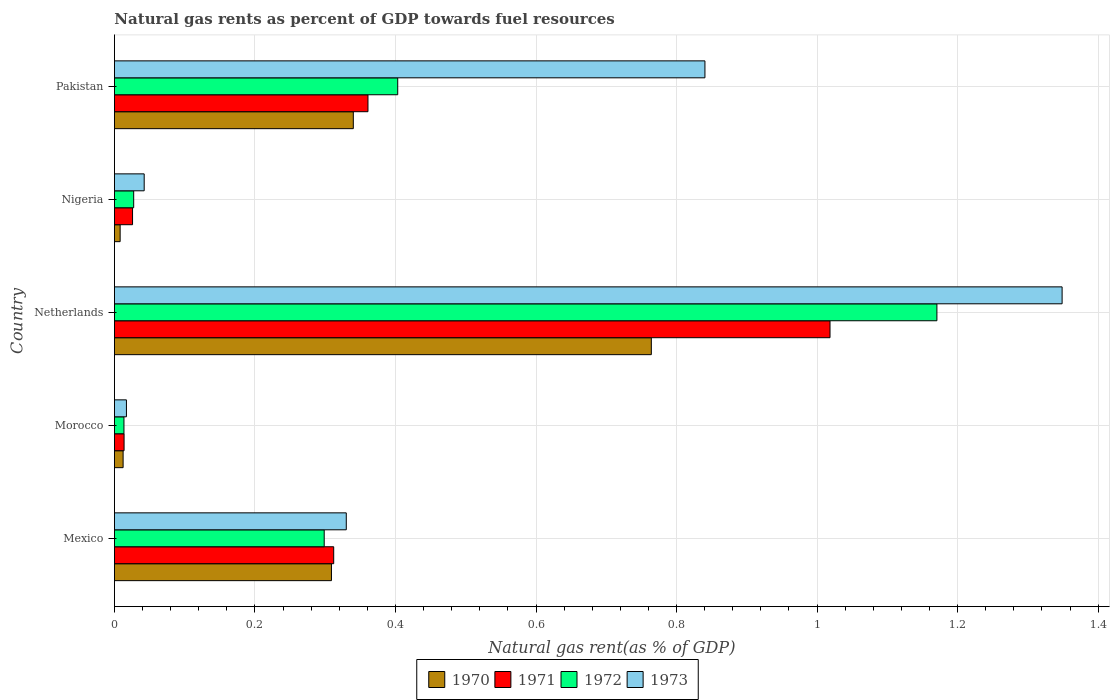How many different coloured bars are there?
Provide a short and direct response. 4. How many groups of bars are there?
Your response must be concise. 5. Are the number of bars on each tick of the Y-axis equal?
Provide a succinct answer. Yes. How many bars are there on the 3rd tick from the bottom?
Make the answer very short. 4. What is the label of the 5th group of bars from the top?
Provide a short and direct response. Mexico. In how many cases, is the number of bars for a given country not equal to the number of legend labels?
Provide a short and direct response. 0. What is the natural gas rent in 1970 in Pakistan?
Your answer should be compact. 0.34. Across all countries, what is the maximum natural gas rent in 1972?
Ensure brevity in your answer.  1.17. Across all countries, what is the minimum natural gas rent in 1970?
Offer a very short reply. 0.01. In which country was the natural gas rent in 1971 maximum?
Give a very brief answer. Netherlands. In which country was the natural gas rent in 1973 minimum?
Offer a terse response. Morocco. What is the total natural gas rent in 1971 in the graph?
Your answer should be compact. 1.73. What is the difference between the natural gas rent in 1972 in Mexico and that in Netherlands?
Ensure brevity in your answer.  -0.87. What is the difference between the natural gas rent in 1972 in Nigeria and the natural gas rent in 1970 in Pakistan?
Keep it short and to the point. -0.31. What is the average natural gas rent in 1973 per country?
Provide a succinct answer. 0.52. What is the difference between the natural gas rent in 1972 and natural gas rent in 1970 in Nigeria?
Your response must be concise. 0.02. What is the ratio of the natural gas rent in 1972 in Nigeria to that in Pakistan?
Your response must be concise. 0.07. Is the natural gas rent in 1970 in Mexico less than that in Nigeria?
Give a very brief answer. No. What is the difference between the highest and the second highest natural gas rent in 1973?
Keep it short and to the point. 0.51. What is the difference between the highest and the lowest natural gas rent in 1971?
Offer a very short reply. 1. In how many countries, is the natural gas rent in 1971 greater than the average natural gas rent in 1971 taken over all countries?
Ensure brevity in your answer.  2. Is it the case that in every country, the sum of the natural gas rent in 1973 and natural gas rent in 1970 is greater than the sum of natural gas rent in 1971 and natural gas rent in 1972?
Keep it short and to the point. No. What does the 2nd bar from the top in Mexico represents?
Offer a very short reply. 1972. How many bars are there?
Your answer should be very brief. 20. Are all the bars in the graph horizontal?
Give a very brief answer. Yes. How many countries are there in the graph?
Your answer should be very brief. 5. Are the values on the major ticks of X-axis written in scientific E-notation?
Offer a very short reply. No. Does the graph contain grids?
Your response must be concise. Yes. What is the title of the graph?
Give a very brief answer. Natural gas rents as percent of GDP towards fuel resources. Does "2002" appear as one of the legend labels in the graph?
Provide a succinct answer. No. What is the label or title of the X-axis?
Your answer should be compact. Natural gas rent(as % of GDP). What is the label or title of the Y-axis?
Ensure brevity in your answer.  Country. What is the Natural gas rent(as % of GDP) of 1970 in Mexico?
Keep it short and to the point. 0.31. What is the Natural gas rent(as % of GDP) in 1971 in Mexico?
Provide a short and direct response. 0.31. What is the Natural gas rent(as % of GDP) of 1972 in Mexico?
Offer a terse response. 0.3. What is the Natural gas rent(as % of GDP) of 1973 in Mexico?
Give a very brief answer. 0.33. What is the Natural gas rent(as % of GDP) in 1970 in Morocco?
Give a very brief answer. 0.01. What is the Natural gas rent(as % of GDP) of 1971 in Morocco?
Provide a succinct answer. 0.01. What is the Natural gas rent(as % of GDP) of 1972 in Morocco?
Offer a terse response. 0.01. What is the Natural gas rent(as % of GDP) in 1973 in Morocco?
Provide a succinct answer. 0.02. What is the Natural gas rent(as % of GDP) in 1970 in Netherlands?
Your answer should be very brief. 0.76. What is the Natural gas rent(as % of GDP) of 1971 in Netherlands?
Give a very brief answer. 1.02. What is the Natural gas rent(as % of GDP) of 1972 in Netherlands?
Your response must be concise. 1.17. What is the Natural gas rent(as % of GDP) in 1973 in Netherlands?
Your answer should be very brief. 1.35. What is the Natural gas rent(as % of GDP) of 1970 in Nigeria?
Keep it short and to the point. 0.01. What is the Natural gas rent(as % of GDP) of 1971 in Nigeria?
Your answer should be very brief. 0.03. What is the Natural gas rent(as % of GDP) of 1972 in Nigeria?
Make the answer very short. 0.03. What is the Natural gas rent(as % of GDP) in 1973 in Nigeria?
Your response must be concise. 0.04. What is the Natural gas rent(as % of GDP) of 1970 in Pakistan?
Offer a terse response. 0.34. What is the Natural gas rent(as % of GDP) in 1971 in Pakistan?
Give a very brief answer. 0.36. What is the Natural gas rent(as % of GDP) of 1972 in Pakistan?
Your answer should be compact. 0.4. What is the Natural gas rent(as % of GDP) of 1973 in Pakistan?
Offer a very short reply. 0.84. Across all countries, what is the maximum Natural gas rent(as % of GDP) of 1970?
Ensure brevity in your answer.  0.76. Across all countries, what is the maximum Natural gas rent(as % of GDP) of 1971?
Keep it short and to the point. 1.02. Across all countries, what is the maximum Natural gas rent(as % of GDP) in 1972?
Keep it short and to the point. 1.17. Across all countries, what is the maximum Natural gas rent(as % of GDP) of 1973?
Offer a terse response. 1.35. Across all countries, what is the minimum Natural gas rent(as % of GDP) of 1970?
Keep it short and to the point. 0.01. Across all countries, what is the minimum Natural gas rent(as % of GDP) of 1971?
Offer a very short reply. 0.01. Across all countries, what is the minimum Natural gas rent(as % of GDP) in 1972?
Provide a short and direct response. 0.01. Across all countries, what is the minimum Natural gas rent(as % of GDP) of 1973?
Keep it short and to the point. 0.02. What is the total Natural gas rent(as % of GDP) in 1970 in the graph?
Offer a very short reply. 1.43. What is the total Natural gas rent(as % of GDP) of 1971 in the graph?
Provide a succinct answer. 1.73. What is the total Natural gas rent(as % of GDP) of 1972 in the graph?
Provide a succinct answer. 1.91. What is the total Natural gas rent(as % of GDP) of 1973 in the graph?
Give a very brief answer. 2.58. What is the difference between the Natural gas rent(as % of GDP) in 1970 in Mexico and that in Morocco?
Keep it short and to the point. 0.3. What is the difference between the Natural gas rent(as % of GDP) of 1971 in Mexico and that in Morocco?
Your response must be concise. 0.3. What is the difference between the Natural gas rent(as % of GDP) of 1972 in Mexico and that in Morocco?
Make the answer very short. 0.28. What is the difference between the Natural gas rent(as % of GDP) in 1973 in Mexico and that in Morocco?
Ensure brevity in your answer.  0.31. What is the difference between the Natural gas rent(as % of GDP) in 1970 in Mexico and that in Netherlands?
Ensure brevity in your answer.  -0.46. What is the difference between the Natural gas rent(as % of GDP) of 1971 in Mexico and that in Netherlands?
Offer a terse response. -0.71. What is the difference between the Natural gas rent(as % of GDP) of 1972 in Mexico and that in Netherlands?
Your answer should be very brief. -0.87. What is the difference between the Natural gas rent(as % of GDP) of 1973 in Mexico and that in Netherlands?
Your answer should be compact. -1.02. What is the difference between the Natural gas rent(as % of GDP) of 1970 in Mexico and that in Nigeria?
Your response must be concise. 0.3. What is the difference between the Natural gas rent(as % of GDP) of 1971 in Mexico and that in Nigeria?
Provide a short and direct response. 0.29. What is the difference between the Natural gas rent(as % of GDP) of 1972 in Mexico and that in Nigeria?
Give a very brief answer. 0.27. What is the difference between the Natural gas rent(as % of GDP) in 1973 in Mexico and that in Nigeria?
Your answer should be very brief. 0.29. What is the difference between the Natural gas rent(as % of GDP) in 1970 in Mexico and that in Pakistan?
Ensure brevity in your answer.  -0.03. What is the difference between the Natural gas rent(as % of GDP) in 1971 in Mexico and that in Pakistan?
Offer a terse response. -0.05. What is the difference between the Natural gas rent(as % of GDP) in 1972 in Mexico and that in Pakistan?
Offer a very short reply. -0.1. What is the difference between the Natural gas rent(as % of GDP) in 1973 in Mexico and that in Pakistan?
Ensure brevity in your answer.  -0.51. What is the difference between the Natural gas rent(as % of GDP) of 1970 in Morocco and that in Netherlands?
Offer a terse response. -0.75. What is the difference between the Natural gas rent(as % of GDP) of 1971 in Morocco and that in Netherlands?
Offer a terse response. -1. What is the difference between the Natural gas rent(as % of GDP) of 1972 in Morocco and that in Netherlands?
Give a very brief answer. -1.16. What is the difference between the Natural gas rent(as % of GDP) of 1973 in Morocco and that in Netherlands?
Offer a terse response. -1.33. What is the difference between the Natural gas rent(as % of GDP) in 1970 in Morocco and that in Nigeria?
Ensure brevity in your answer.  0. What is the difference between the Natural gas rent(as % of GDP) in 1971 in Morocco and that in Nigeria?
Your answer should be compact. -0.01. What is the difference between the Natural gas rent(as % of GDP) in 1972 in Morocco and that in Nigeria?
Give a very brief answer. -0.01. What is the difference between the Natural gas rent(as % of GDP) in 1973 in Morocco and that in Nigeria?
Give a very brief answer. -0.03. What is the difference between the Natural gas rent(as % of GDP) of 1970 in Morocco and that in Pakistan?
Your response must be concise. -0.33. What is the difference between the Natural gas rent(as % of GDP) of 1971 in Morocco and that in Pakistan?
Offer a terse response. -0.35. What is the difference between the Natural gas rent(as % of GDP) in 1972 in Morocco and that in Pakistan?
Your response must be concise. -0.39. What is the difference between the Natural gas rent(as % of GDP) in 1973 in Morocco and that in Pakistan?
Your answer should be compact. -0.82. What is the difference between the Natural gas rent(as % of GDP) of 1970 in Netherlands and that in Nigeria?
Make the answer very short. 0.76. What is the difference between the Natural gas rent(as % of GDP) in 1971 in Netherlands and that in Nigeria?
Give a very brief answer. 0.99. What is the difference between the Natural gas rent(as % of GDP) in 1972 in Netherlands and that in Nigeria?
Your answer should be very brief. 1.14. What is the difference between the Natural gas rent(as % of GDP) in 1973 in Netherlands and that in Nigeria?
Provide a short and direct response. 1.31. What is the difference between the Natural gas rent(as % of GDP) of 1970 in Netherlands and that in Pakistan?
Make the answer very short. 0.42. What is the difference between the Natural gas rent(as % of GDP) of 1971 in Netherlands and that in Pakistan?
Your answer should be very brief. 0.66. What is the difference between the Natural gas rent(as % of GDP) of 1972 in Netherlands and that in Pakistan?
Offer a very short reply. 0.77. What is the difference between the Natural gas rent(as % of GDP) of 1973 in Netherlands and that in Pakistan?
Your answer should be compact. 0.51. What is the difference between the Natural gas rent(as % of GDP) of 1970 in Nigeria and that in Pakistan?
Provide a succinct answer. -0.33. What is the difference between the Natural gas rent(as % of GDP) in 1971 in Nigeria and that in Pakistan?
Provide a short and direct response. -0.34. What is the difference between the Natural gas rent(as % of GDP) of 1972 in Nigeria and that in Pakistan?
Make the answer very short. -0.38. What is the difference between the Natural gas rent(as % of GDP) of 1973 in Nigeria and that in Pakistan?
Offer a very short reply. -0.8. What is the difference between the Natural gas rent(as % of GDP) of 1970 in Mexico and the Natural gas rent(as % of GDP) of 1971 in Morocco?
Your answer should be compact. 0.3. What is the difference between the Natural gas rent(as % of GDP) of 1970 in Mexico and the Natural gas rent(as % of GDP) of 1972 in Morocco?
Offer a terse response. 0.3. What is the difference between the Natural gas rent(as % of GDP) in 1970 in Mexico and the Natural gas rent(as % of GDP) in 1973 in Morocco?
Ensure brevity in your answer.  0.29. What is the difference between the Natural gas rent(as % of GDP) in 1971 in Mexico and the Natural gas rent(as % of GDP) in 1972 in Morocco?
Make the answer very short. 0.3. What is the difference between the Natural gas rent(as % of GDP) of 1971 in Mexico and the Natural gas rent(as % of GDP) of 1973 in Morocco?
Offer a very short reply. 0.29. What is the difference between the Natural gas rent(as % of GDP) in 1972 in Mexico and the Natural gas rent(as % of GDP) in 1973 in Morocco?
Offer a very short reply. 0.28. What is the difference between the Natural gas rent(as % of GDP) of 1970 in Mexico and the Natural gas rent(as % of GDP) of 1971 in Netherlands?
Give a very brief answer. -0.71. What is the difference between the Natural gas rent(as % of GDP) in 1970 in Mexico and the Natural gas rent(as % of GDP) in 1972 in Netherlands?
Your answer should be compact. -0.86. What is the difference between the Natural gas rent(as % of GDP) in 1970 in Mexico and the Natural gas rent(as % of GDP) in 1973 in Netherlands?
Keep it short and to the point. -1.04. What is the difference between the Natural gas rent(as % of GDP) in 1971 in Mexico and the Natural gas rent(as % of GDP) in 1972 in Netherlands?
Your answer should be compact. -0.86. What is the difference between the Natural gas rent(as % of GDP) of 1971 in Mexico and the Natural gas rent(as % of GDP) of 1973 in Netherlands?
Provide a succinct answer. -1.04. What is the difference between the Natural gas rent(as % of GDP) of 1972 in Mexico and the Natural gas rent(as % of GDP) of 1973 in Netherlands?
Your answer should be compact. -1.05. What is the difference between the Natural gas rent(as % of GDP) of 1970 in Mexico and the Natural gas rent(as % of GDP) of 1971 in Nigeria?
Offer a terse response. 0.28. What is the difference between the Natural gas rent(as % of GDP) in 1970 in Mexico and the Natural gas rent(as % of GDP) in 1972 in Nigeria?
Your answer should be compact. 0.28. What is the difference between the Natural gas rent(as % of GDP) of 1970 in Mexico and the Natural gas rent(as % of GDP) of 1973 in Nigeria?
Provide a short and direct response. 0.27. What is the difference between the Natural gas rent(as % of GDP) of 1971 in Mexico and the Natural gas rent(as % of GDP) of 1972 in Nigeria?
Offer a very short reply. 0.28. What is the difference between the Natural gas rent(as % of GDP) in 1971 in Mexico and the Natural gas rent(as % of GDP) in 1973 in Nigeria?
Give a very brief answer. 0.27. What is the difference between the Natural gas rent(as % of GDP) of 1972 in Mexico and the Natural gas rent(as % of GDP) of 1973 in Nigeria?
Give a very brief answer. 0.26. What is the difference between the Natural gas rent(as % of GDP) of 1970 in Mexico and the Natural gas rent(as % of GDP) of 1971 in Pakistan?
Your response must be concise. -0.05. What is the difference between the Natural gas rent(as % of GDP) of 1970 in Mexico and the Natural gas rent(as % of GDP) of 1972 in Pakistan?
Give a very brief answer. -0.09. What is the difference between the Natural gas rent(as % of GDP) of 1970 in Mexico and the Natural gas rent(as % of GDP) of 1973 in Pakistan?
Provide a succinct answer. -0.53. What is the difference between the Natural gas rent(as % of GDP) of 1971 in Mexico and the Natural gas rent(as % of GDP) of 1972 in Pakistan?
Provide a succinct answer. -0.09. What is the difference between the Natural gas rent(as % of GDP) of 1971 in Mexico and the Natural gas rent(as % of GDP) of 1973 in Pakistan?
Make the answer very short. -0.53. What is the difference between the Natural gas rent(as % of GDP) in 1972 in Mexico and the Natural gas rent(as % of GDP) in 1973 in Pakistan?
Provide a short and direct response. -0.54. What is the difference between the Natural gas rent(as % of GDP) of 1970 in Morocco and the Natural gas rent(as % of GDP) of 1971 in Netherlands?
Give a very brief answer. -1.01. What is the difference between the Natural gas rent(as % of GDP) in 1970 in Morocco and the Natural gas rent(as % of GDP) in 1972 in Netherlands?
Make the answer very short. -1.16. What is the difference between the Natural gas rent(as % of GDP) in 1970 in Morocco and the Natural gas rent(as % of GDP) in 1973 in Netherlands?
Offer a terse response. -1.34. What is the difference between the Natural gas rent(as % of GDP) of 1971 in Morocco and the Natural gas rent(as % of GDP) of 1972 in Netherlands?
Provide a succinct answer. -1.16. What is the difference between the Natural gas rent(as % of GDP) of 1971 in Morocco and the Natural gas rent(as % of GDP) of 1973 in Netherlands?
Offer a very short reply. -1.33. What is the difference between the Natural gas rent(as % of GDP) in 1972 in Morocco and the Natural gas rent(as % of GDP) in 1973 in Netherlands?
Make the answer very short. -1.34. What is the difference between the Natural gas rent(as % of GDP) of 1970 in Morocco and the Natural gas rent(as % of GDP) of 1971 in Nigeria?
Provide a short and direct response. -0.01. What is the difference between the Natural gas rent(as % of GDP) of 1970 in Morocco and the Natural gas rent(as % of GDP) of 1972 in Nigeria?
Ensure brevity in your answer.  -0.02. What is the difference between the Natural gas rent(as % of GDP) in 1970 in Morocco and the Natural gas rent(as % of GDP) in 1973 in Nigeria?
Keep it short and to the point. -0.03. What is the difference between the Natural gas rent(as % of GDP) in 1971 in Morocco and the Natural gas rent(as % of GDP) in 1972 in Nigeria?
Offer a terse response. -0.01. What is the difference between the Natural gas rent(as % of GDP) in 1971 in Morocco and the Natural gas rent(as % of GDP) in 1973 in Nigeria?
Offer a very short reply. -0.03. What is the difference between the Natural gas rent(as % of GDP) of 1972 in Morocco and the Natural gas rent(as % of GDP) of 1973 in Nigeria?
Provide a succinct answer. -0.03. What is the difference between the Natural gas rent(as % of GDP) of 1970 in Morocco and the Natural gas rent(as % of GDP) of 1971 in Pakistan?
Give a very brief answer. -0.35. What is the difference between the Natural gas rent(as % of GDP) of 1970 in Morocco and the Natural gas rent(as % of GDP) of 1972 in Pakistan?
Offer a very short reply. -0.39. What is the difference between the Natural gas rent(as % of GDP) in 1970 in Morocco and the Natural gas rent(as % of GDP) in 1973 in Pakistan?
Ensure brevity in your answer.  -0.83. What is the difference between the Natural gas rent(as % of GDP) in 1971 in Morocco and the Natural gas rent(as % of GDP) in 1972 in Pakistan?
Offer a terse response. -0.39. What is the difference between the Natural gas rent(as % of GDP) in 1971 in Morocco and the Natural gas rent(as % of GDP) in 1973 in Pakistan?
Give a very brief answer. -0.83. What is the difference between the Natural gas rent(as % of GDP) of 1972 in Morocco and the Natural gas rent(as % of GDP) of 1973 in Pakistan?
Offer a terse response. -0.83. What is the difference between the Natural gas rent(as % of GDP) in 1970 in Netherlands and the Natural gas rent(as % of GDP) in 1971 in Nigeria?
Ensure brevity in your answer.  0.74. What is the difference between the Natural gas rent(as % of GDP) in 1970 in Netherlands and the Natural gas rent(as % of GDP) in 1972 in Nigeria?
Your answer should be compact. 0.74. What is the difference between the Natural gas rent(as % of GDP) in 1970 in Netherlands and the Natural gas rent(as % of GDP) in 1973 in Nigeria?
Provide a succinct answer. 0.72. What is the difference between the Natural gas rent(as % of GDP) in 1971 in Netherlands and the Natural gas rent(as % of GDP) in 1972 in Nigeria?
Ensure brevity in your answer.  0.99. What is the difference between the Natural gas rent(as % of GDP) of 1971 in Netherlands and the Natural gas rent(as % of GDP) of 1973 in Nigeria?
Give a very brief answer. 0.98. What is the difference between the Natural gas rent(as % of GDP) of 1972 in Netherlands and the Natural gas rent(as % of GDP) of 1973 in Nigeria?
Offer a terse response. 1.13. What is the difference between the Natural gas rent(as % of GDP) in 1970 in Netherlands and the Natural gas rent(as % of GDP) in 1971 in Pakistan?
Provide a succinct answer. 0.4. What is the difference between the Natural gas rent(as % of GDP) of 1970 in Netherlands and the Natural gas rent(as % of GDP) of 1972 in Pakistan?
Ensure brevity in your answer.  0.36. What is the difference between the Natural gas rent(as % of GDP) in 1970 in Netherlands and the Natural gas rent(as % of GDP) in 1973 in Pakistan?
Make the answer very short. -0.08. What is the difference between the Natural gas rent(as % of GDP) of 1971 in Netherlands and the Natural gas rent(as % of GDP) of 1972 in Pakistan?
Give a very brief answer. 0.62. What is the difference between the Natural gas rent(as % of GDP) in 1971 in Netherlands and the Natural gas rent(as % of GDP) in 1973 in Pakistan?
Offer a terse response. 0.18. What is the difference between the Natural gas rent(as % of GDP) of 1972 in Netherlands and the Natural gas rent(as % of GDP) of 1973 in Pakistan?
Provide a short and direct response. 0.33. What is the difference between the Natural gas rent(as % of GDP) of 1970 in Nigeria and the Natural gas rent(as % of GDP) of 1971 in Pakistan?
Give a very brief answer. -0.35. What is the difference between the Natural gas rent(as % of GDP) in 1970 in Nigeria and the Natural gas rent(as % of GDP) in 1972 in Pakistan?
Your response must be concise. -0.4. What is the difference between the Natural gas rent(as % of GDP) of 1970 in Nigeria and the Natural gas rent(as % of GDP) of 1973 in Pakistan?
Give a very brief answer. -0.83. What is the difference between the Natural gas rent(as % of GDP) in 1971 in Nigeria and the Natural gas rent(as % of GDP) in 1972 in Pakistan?
Your response must be concise. -0.38. What is the difference between the Natural gas rent(as % of GDP) of 1971 in Nigeria and the Natural gas rent(as % of GDP) of 1973 in Pakistan?
Keep it short and to the point. -0.81. What is the difference between the Natural gas rent(as % of GDP) in 1972 in Nigeria and the Natural gas rent(as % of GDP) in 1973 in Pakistan?
Your answer should be very brief. -0.81. What is the average Natural gas rent(as % of GDP) of 1970 per country?
Your answer should be compact. 0.29. What is the average Natural gas rent(as % of GDP) in 1971 per country?
Your answer should be very brief. 0.35. What is the average Natural gas rent(as % of GDP) in 1972 per country?
Keep it short and to the point. 0.38. What is the average Natural gas rent(as % of GDP) in 1973 per country?
Your response must be concise. 0.52. What is the difference between the Natural gas rent(as % of GDP) of 1970 and Natural gas rent(as % of GDP) of 1971 in Mexico?
Offer a very short reply. -0. What is the difference between the Natural gas rent(as % of GDP) in 1970 and Natural gas rent(as % of GDP) in 1972 in Mexico?
Offer a very short reply. 0.01. What is the difference between the Natural gas rent(as % of GDP) of 1970 and Natural gas rent(as % of GDP) of 1973 in Mexico?
Ensure brevity in your answer.  -0.02. What is the difference between the Natural gas rent(as % of GDP) in 1971 and Natural gas rent(as % of GDP) in 1972 in Mexico?
Your response must be concise. 0.01. What is the difference between the Natural gas rent(as % of GDP) of 1971 and Natural gas rent(as % of GDP) of 1973 in Mexico?
Give a very brief answer. -0.02. What is the difference between the Natural gas rent(as % of GDP) of 1972 and Natural gas rent(as % of GDP) of 1973 in Mexico?
Provide a succinct answer. -0.03. What is the difference between the Natural gas rent(as % of GDP) of 1970 and Natural gas rent(as % of GDP) of 1971 in Morocco?
Give a very brief answer. -0. What is the difference between the Natural gas rent(as % of GDP) in 1970 and Natural gas rent(as % of GDP) in 1972 in Morocco?
Your answer should be compact. -0. What is the difference between the Natural gas rent(as % of GDP) in 1970 and Natural gas rent(as % of GDP) in 1973 in Morocco?
Keep it short and to the point. -0. What is the difference between the Natural gas rent(as % of GDP) in 1971 and Natural gas rent(as % of GDP) in 1972 in Morocco?
Make the answer very short. 0. What is the difference between the Natural gas rent(as % of GDP) of 1971 and Natural gas rent(as % of GDP) of 1973 in Morocco?
Offer a very short reply. -0. What is the difference between the Natural gas rent(as % of GDP) of 1972 and Natural gas rent(as % of GDP) of 1973 in Morocco?
Make the answer very short. -0. What is the difference between the Natural gas rent(as % of GDP) of 1970 and Natural gas rent(as % of GDP) of 1971 in Netherlands?
Keep it short and to the point. -0.25. What is the difference between the Natural gas rent(as % of GDP) in 1970 and Natural gas rent(as % of GDP) in 1972 in Netherlands?
Make the answer very short. -0.41. What is the difference between the Natural gas rent(as % of GDP) in 1970 and Natural gas rent(as % of GDP) in 1973 in Netherlands?
Provide a succinct answer. -0.58. What is the difference between the Natural gas rent(as % of GDP) of 1971 and Natural gas rent(as % of GDP) of 1972 in Netherlands?
Ensure brevity in your answer.  -0.15. What is the difference between the Natural gas rent(as % of GDP) of 1971 and Natural gas rent(as % of GDP) of 1973 in Netherlands?
Provide a short and direct response. -0.33. What is the difference between the Natural gas rent(as % of GDP) of 1972 and Natural gas rent(as % of GDP) of 1973 in Netherlands?
Offer a very short reply. -0.18. What is the difference between the Natural gas rent(as % of GDP) in 1970 and Natural gas rent(as % of GDP) in 1971 in Nigeria?
Keep it short and to the point. -0.02. What is the difference between the Natural gas rent(as % of GDP) in 1970 and Natural gas rent(as % of GDP) in 1972 in Nigeria?
Provide a short and direct response. -0.02. What is the difference between the Natural gas rent(as % of GDP) in 1970 and Natural gas rent(as % of GDP) in 1973 in Nigeria?
Offer a very short reply. -0.03. What is the difference between the Natural gas rent(as % of GDP) of 1971 and Natural gas rent(as % of GDP) of 1972 in Nigeria?
Your response must be concise. -0. What is the difference between the Natural gas rent(as % of GDP) of 1971 and Natural gas rent(as % of GDP) of 1973 in Nigeria?
Your response must be concise. -0.02. What is the difference between the Natural gas rent(as % of GDP) in 1972 and Natural gas rent(as % of GDP) in 1973 in Nigeria?
Provide a succinct answer. -0.01. What is the difference between the Natural gas rent(as % of GDP) of 1970 and Natural gas rent(as % of GDP) of 1971 in Pakistan?
Your response must be concise. -0.02. What is the difference between the Natural gas rent(as % of GDP) in 1970 and Natural gas rent(as % of GDP) in 1972 in Pakistan?
Keep it short and to the point. -0.06. What is the difference between the Natural gas rent(as % of GDP) in 1970 and Natural gas rent(as % of GDP) in 1973 in Pakistan?
Provide a short and direct response. -0.5. What is the difference between the Natural gas rent(as % of GDP) of 1971 and Natural gas rent(as % of GDP) of 1972 in Pakistan?
Your response must be concise. -0.04. What is the difference between the Natural gas rent(as % of GDP) in 1971 and Natural gas rent(as % of GDP) in 1973 in Pakistan?
Ensure brevity in your answer.  -0.48. What is the difference between the Natural gas rent(as % of GDP) of 1972 and Natural gas rent(as % of GDP) of 1973 in Pakistan?
Offer a very short reply. -0.44. What is the ratio of the Natural gas rent(as % of GDP) of 1970 in Mexico to that in Morocco?
Give a very brief answer. 25. What is the ratio of the Natural gas rent(as % of GDP) in 1971 in Mexico to that in Morocco?
Your answer should be compact. 22.74. What is the ratio of the Natural gas rent(as % of GDP) in 1972 in Mexico to that in Morocco?
Provide a succinct answer. 22.04. What is the ratio of the Natural gas rent(as % of GDP) in 1973 in Mexico to that in Morocco?
Give a very brief answer. 19.3. What is the ratio of the Natural gas rent(as % of GDP) of 1970 in Mexico to that in Netherlands?
Offer a terse response. 0.4. What is the ratio of the Natural gas rent(as % of GDP) in 1971 in Mexico to that in Netherlands?
Provide a succinct answer. 0.31. What is the ratio of the Natural gas rent(as % of GDP) of 1972 in Mexico to that in Netherlands?
Offer a terse response. 0.26. What is the ratio of the Natural gas rent(as % of GDP) in 1973 in Mexico to that in Netherlands?
Offer a terse response. 0.24. What is the ratio of the Natural gas rent(as % of GDP) in 1970 in Mexico to that in Nigeria?
Your answer should be compact. 37.97. What is the ratio of the Natural gas rent(as % of GDP) in 1971 in Mexico to that in Nigeria?
Your response must be concise. 12.1. What is the ratio of the Natural gas rent(as % of GDP) of 1972 in Mexico to that in Nigeria?
Your response must be concise. 10.89. What is the ratio of the Natural gas rent(as % of GDP) in 1973 in Mexico to that in Nigeria?
Offer a very short reply. 7.79. What is the ratio of the Natural gas rent(as % of GDP) of 1970 in Mexico to that in Pakistan?
Your response must be concise. 0.91. What is the ratio of the Natural gas rent(as % of GDP) of 1971 in Mexico to that in Pakistan?
Make the answer very short. 0.86. What is the ratio of the Natural gas rent(as % of GDP) in 1972 in Mexico to that in Pakistan?
Ensure brevity in your answer.  0.74. What is the ratio of the Natural gas rent(as % of GDP) of 1973 in Mexico to that in Pakistan?
Offer a very short reply. 0.39. What is the ratio of the Natural gas rent(as % of GDP) of 1970 in Morocco to that in Netherlands?
Provide a short and direct response. 0.02. What is the ratio of the Natural gas rent(as % of GDP) of 1971 in Morocco to that in Netherlands?
Ensure brevity in your answer.  0.01. What is the ratio of the Natural gas rent(as % of GDP) of 1972 in Morocco to that in Netherlands?
Provide a short and direct response. 0.01. What is the ratio of the Natural gas rent(as % of GDP) in 1973 in Morocco to that in Netherlands?
Provide a succinct answer. 0.01. What is the ratio of the Natural gas rent(as % of GDP) in 1970 in Morocco to that in Nigeria?
Provide a short and direct response. 1.52. What is the ratio of the Natural gas rent(as % of GDP) in 1971 in Morocco to that in Nigeria?
Offer a very short reply. 0.53. What is the ratio of the Natural gas rent(as % of GDP) of 1972 in Morocco to that in Nigeria?
Offer a terse response. 0.49. What is the ratio of the Natural gas rent(as % of GDP) of 1973 in Morocco to that in Nigeria?
Keep it short and to the point. 0.4. What is the ratio of the Natural gas rent(as % of GDP) in 1970 in Morocco to that in Pakistan?
Ensure brevity in your answer.  0.04. What is the ratio of the Natural gas rent(as % of GDP) in 1971 in Morocco to that in Pakistan?
Provide a short and direct response. 0.04. What is the ratio of the Natural gas rent(as % of GDP) in 1972 in Morocco to that in Pakistan?
Keep it short and to the point. 0.03. What is the ratio of the Natural gas rent(as % of GDP) in 1973 in Morocco to that in Pakistan?
Your answer should be compact. 0.02. What is the ratio of the Natural gas rent(as % of GDP) of 1970 in Netherlands to that in Nigeria?
Offer a terse response. 93.94. What is the ratio of the Natural gas rent(as % of GDP) of 1971 in Netherlands to that in Nigeria?
Your answer should be very brief. 39.48. What is the ratio of the Natural gas rent(as % of GDP) of 1972 in Netherlands to that in Nigeria?
Your answer should be compact. 42.7. What is the ratio of the Natural gas rent(as % of GDP) in 1973 in Netherlands to that in Nigeria?
Your answer should be compact. 31.84. What is the ratio of the Natural gas rent(as % of GDP) in 1970 in Netherlands to that in Pakistan?
Your response must be concise. 2.25. What is the ratio of the Natural gas rent(as % of GDP) in 1971 in Netherlands to that in Pakistan?
Keep it short and to the point. 2.82. What is the ratio of the Natural gas rent(as % of GDP) of 1972 in Netherlands to that in Pakistan?
Ensure brevity in your answer.  2.9. What is the ratio of the Natural gas rent(as % of GDP) of 1973 in Netherlands to that in Pakistan?
Your answer should be compact. 1.6. What is the ratio of the Natural gas rent(as % of GDP) in 1970 in Nigeria to that in Pakistan?
Give a very brief answer. 0.02. What is the ratio of the Natural gas rent(as % of GDP) in 1971 in Nigeria to that in Pakistan?
Offer a very short reply. 0.07. What is the ratio of the Natural gas rent(as % of GDP) in 1972 in Nigeria to that in Pakistan?
Give a very brief answer. 0.07. What is the ratio of the Natural gas rent(as % of GDP) of 1973 in Nigeria to that in Pakistan?
Your response must be concise. 0.05. What is the difference between the highest and the second highest Natural gas rent(as % of GDP) in 1970?
Ensure brevity in your answer.  0.42. What is the difference between the highest and the second highest Natural gas rent(as % of GDP) in 1971?
Make the answer very short. 0.66. What is the difference between the highest and the second highest Natural gas rent(as % of GDP) in 1972?
Offer a terse response. 0.77. What is the difference between the highest and the second highest Natural gas rent(as % of GDP) in 1973?
Your answer should be very brief. 0.51. What is the difference between the highest and the lowest Natural gas rent(as % of GDP) of 1970?
Offer a terse response. 0.76. What is the difference between the highest and the lowest Natural gas rent(as % of GDP) of 1971?
Your answer should be very brief. 1. What is the difference between the highest and the lowest Natural gas rent(as % of GDP) in 1972?
Your response must be concise. 1.16. What is the difference between the highest and the lowest Natural gas rent(as % of GDP) of 1973?
Offer a very short reply. 1.33. 